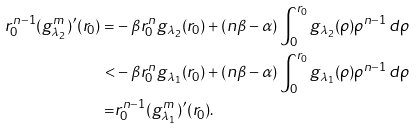<formula> <loc_0><loc_0><loc_500><loc_500>r _ { 0 } ^ { n - 1 } ( g _ { \lambda _ { 2 } } ^ { m } ) ^ { \prime } ( r _ { 0 } ) = & - \beta r _ { 0 } ^ { n } g _ { \lambda _ { 2 } } ( r _ { 0 } ) + ( n \beta - \alpha ) \int _ { 0 } ^ { r _ { 0 } } g _ { \lambda _ { 2 } } ( \rho ) \rho ^ { n - 1 } \, d \rho \\ < & - \beta r _ { 0 } ^ { n } g _ { \lambda _ { 1 } } ( r _ { 0 } ) + ( n \beta - \alpha ) \int _ { 0 } ^ { r _ { 0 } } g _ { \lambda _ { 1 } } ( \rho ) \rho ^ { n - 1 } \, d \rho \\ = & r _ { 0 } ^ { n - 1 } ( g _ { \lambda _ { 1 } } ^ { m } ) ^ { \prime } ( r _ { 0 } ) .</formula> 